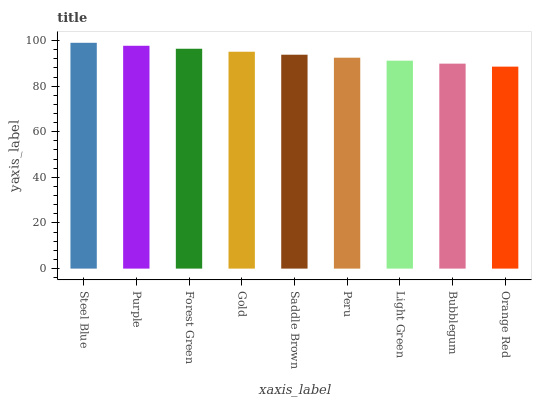Is Orange Red the minimum?
Answer yes or no. Yes. Is Steel Blue the maximum?
Answer yes or no. Yes. Is Purple the minimum?
Answer yes or no. No. Is Purple the maximum?
Answer yes or no. No. Is Steel Blue greater than Purple?
Answer yes or no. Yes. Is Purple less than Steel Blue?
Answer yes or no. Yes. Is Purple greater than Steel Blue?
Answer yes or no. No. Is Steel Blue less than Purple?
Answer yes or no. No. Is Saddle Brown the high median?
Answer yes or no. Yes. Is Saddle Brown the low median?
Answer yes or no. Yes. Is Purple the high median?
Answer yes or no. No. Is Orange Red the low median?
Answer yes or no. No. 